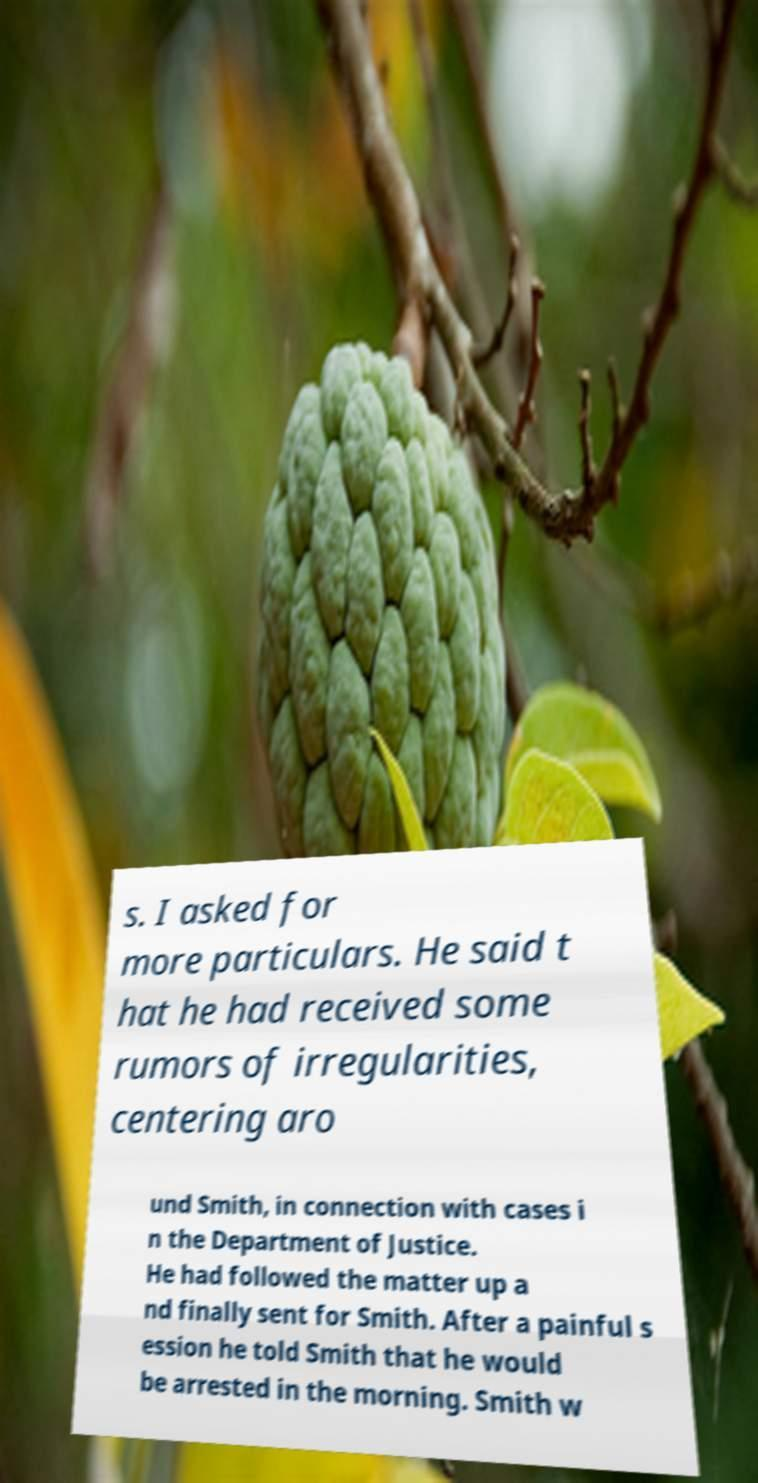Please read and relay the text visible in this image. What does it say? s. I asked for more particulars. He said t hat he had received some rumors of irregularities, centering aro und Smith, in connection with cases i n the Department of Justice. He had followed the matter up a nd finally sent for Smith. After a painful s ession he told Smith that he would be arrested in the morning. Smith w 